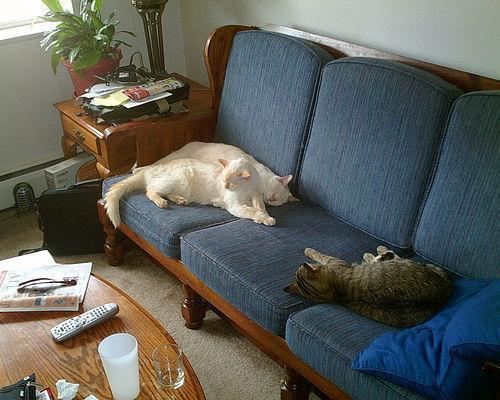How many cups sit on the coffee table?
Give a very brief answer. 2. How many cats are in the picture?
Give a very brief answer. 3. How many people running with a kite on the sand?
Give a very brief answer. 0. 